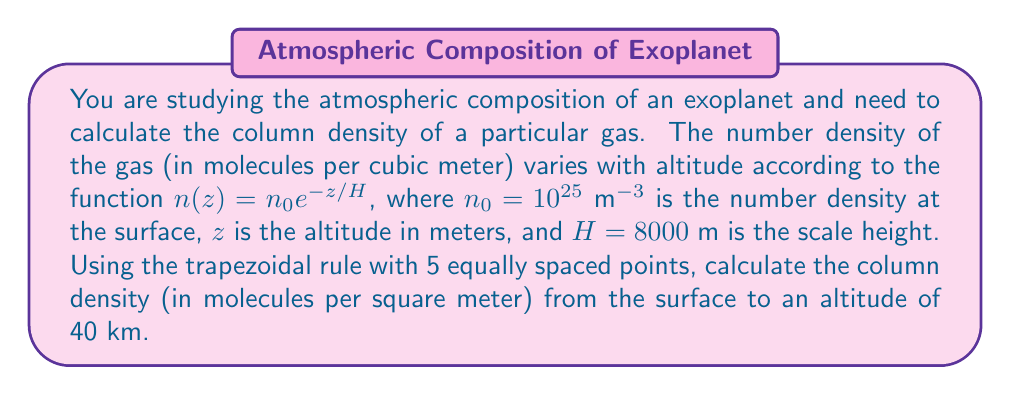Help me with this question. To solve this problem, we'll follow these steps:

1) The column density is the integral of the number density from the surface to the top of the atmosphere:

   $$N = \int_0^{40000} n(z) dz = \int_0^{40000} n_0 e^{-z/H} dz$$

2) We'll use the trapezoidal rule with 5 points. The formula is:

   $$\int_a^b f(x) dx \approx \frac{h}{2}[f(x_0) + 2f(x_1) + 2f(x_2) + 2f(x_3) + f(x_4)]$$

   where $h = (b-a)/(n-1)$ and $n$ is the number of points.

3) Calculate $h$:
   $h = (40000 - 0)/(5-1) = 10000$ m

4) Calculate the function values at each point:
   $f(x_0) = n_0 e^{-0/H} = 10^{25}$
   $f(x_1) = n_0 e^{-10000/8000} = 2.868 \times 10^{24}$
   $f(x_2) = n_0 e^{-20000/8000} = 8.230 \times 10^{23}$
   $f(x_3) = n_0 e^{-30000/8000} = 2.363 \times 10^{23}$
   $f(x_4) = n_0 e^{-40000/8000} = 6.783 \times 10^{22}$

5) Apply the trapezoidal rule:

   $$N \approx \frac{10000}{2}[10^{25} + 2(2.868 \times 10^{24}) + 2(8.230 \times 10^{23}) + 2(2.363 \times 10^{23}) + 6.783 \times 10^{22}]$$

6) Simplify:
   $$N \approx 5000[1.000 \times 10^{25} + 5.736 \times 10^{24} + 1.646 \times 10^{24} + 4.726 \times 10^{23} + 6.783 \times 10^{22}]$$
   $$N \approx 5000[1.785 \times 10^{25}] = 8.925 \times 10^{28}$$

Therefore, the column density is approximately $8.925 \times 10^{28}$ molecules/m².
Answer: $8.925 \times 10^{28}$ molecules/m² 